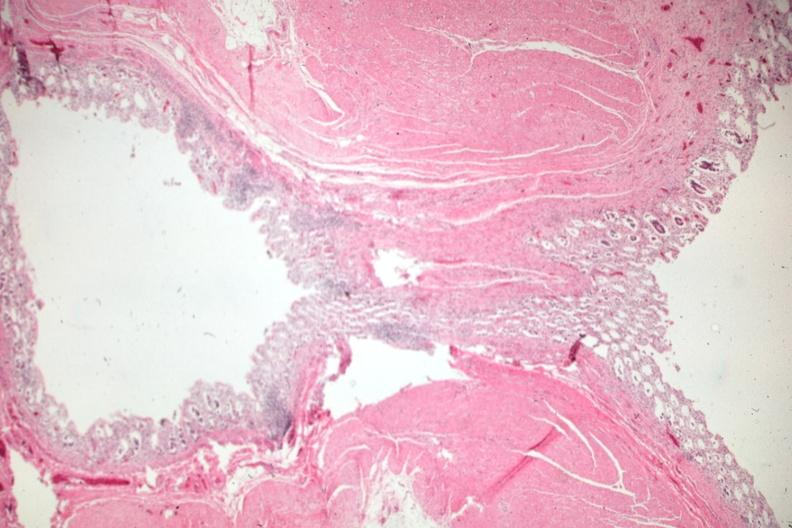does cardiovascular show exceptional view of an uncomplicated diverticulum?
Answer the question using a single word or phrase. No 